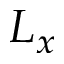<formula> <loc_0><loc_0><loc_500><loc_500>L _ { x }</formula> 